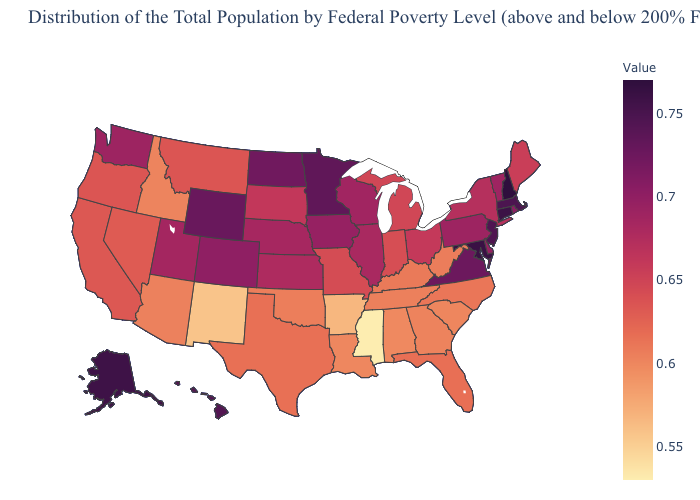Which states have the lowest value in the West?
Quick response, please. New Mexico. Is the legend a continuous bar?
Keep it brief. Yes. Does the map have missing data?
Quick response, please. No. Which states have the lowest value in the USA?
Keep it brief. Mississippi. Which states have the highest value in the USA?
Concise answer only. New Hampshire. 